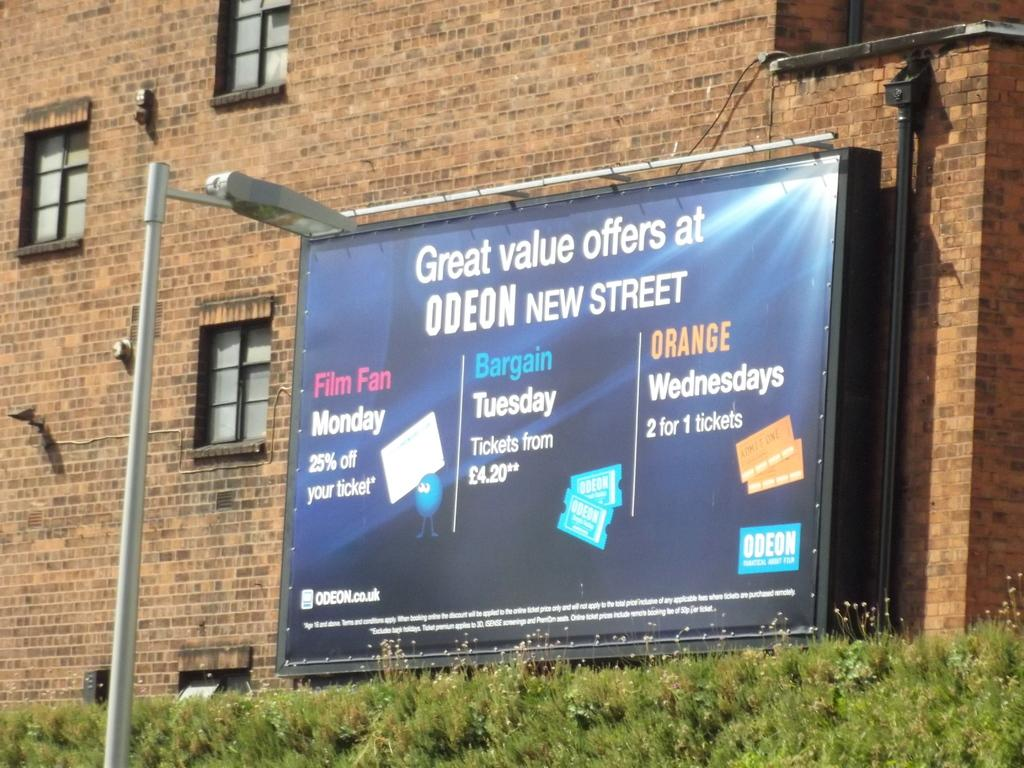<image>
Provide a brief description of the given image. a billboard that says 'great value offers at odeon new street' on it 